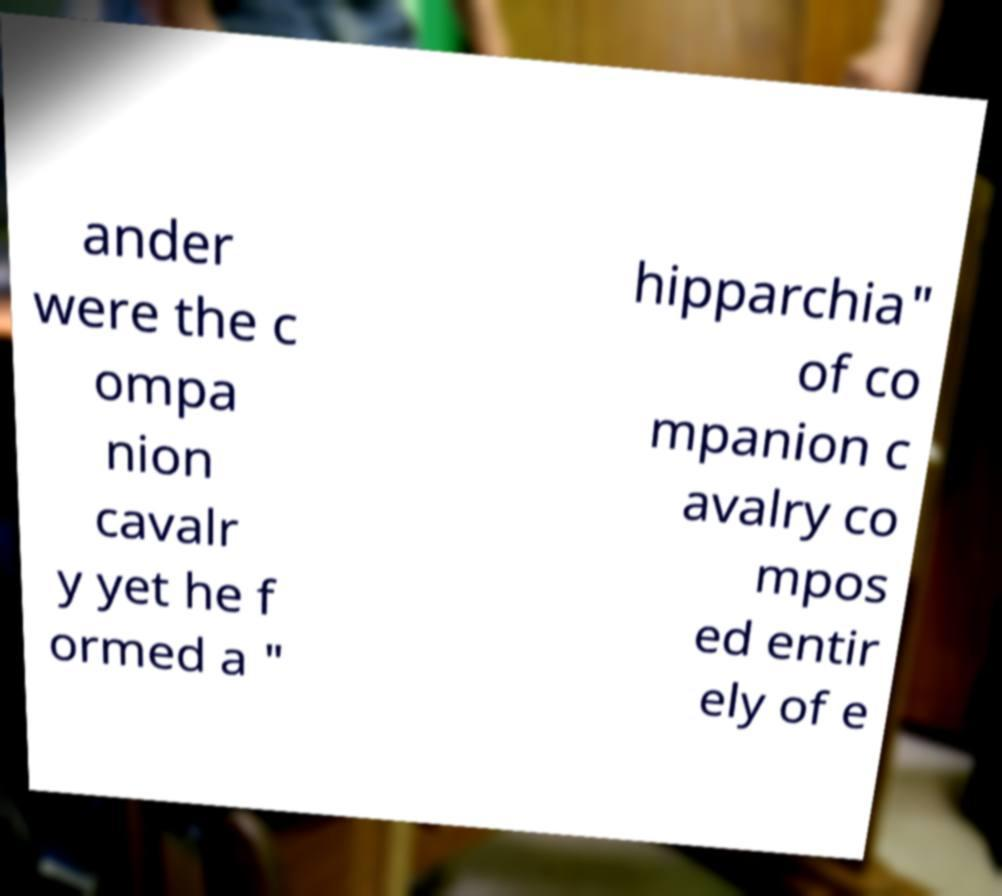Can you read and provide the text displayed in the image?This photo seems to have some interesting text. Can you extract and type it out for me? ander were the c ompa nion cavalr y yet he f ormed a " hipparchia" of co mpanion c avalry co mpos ed entir ely of e 